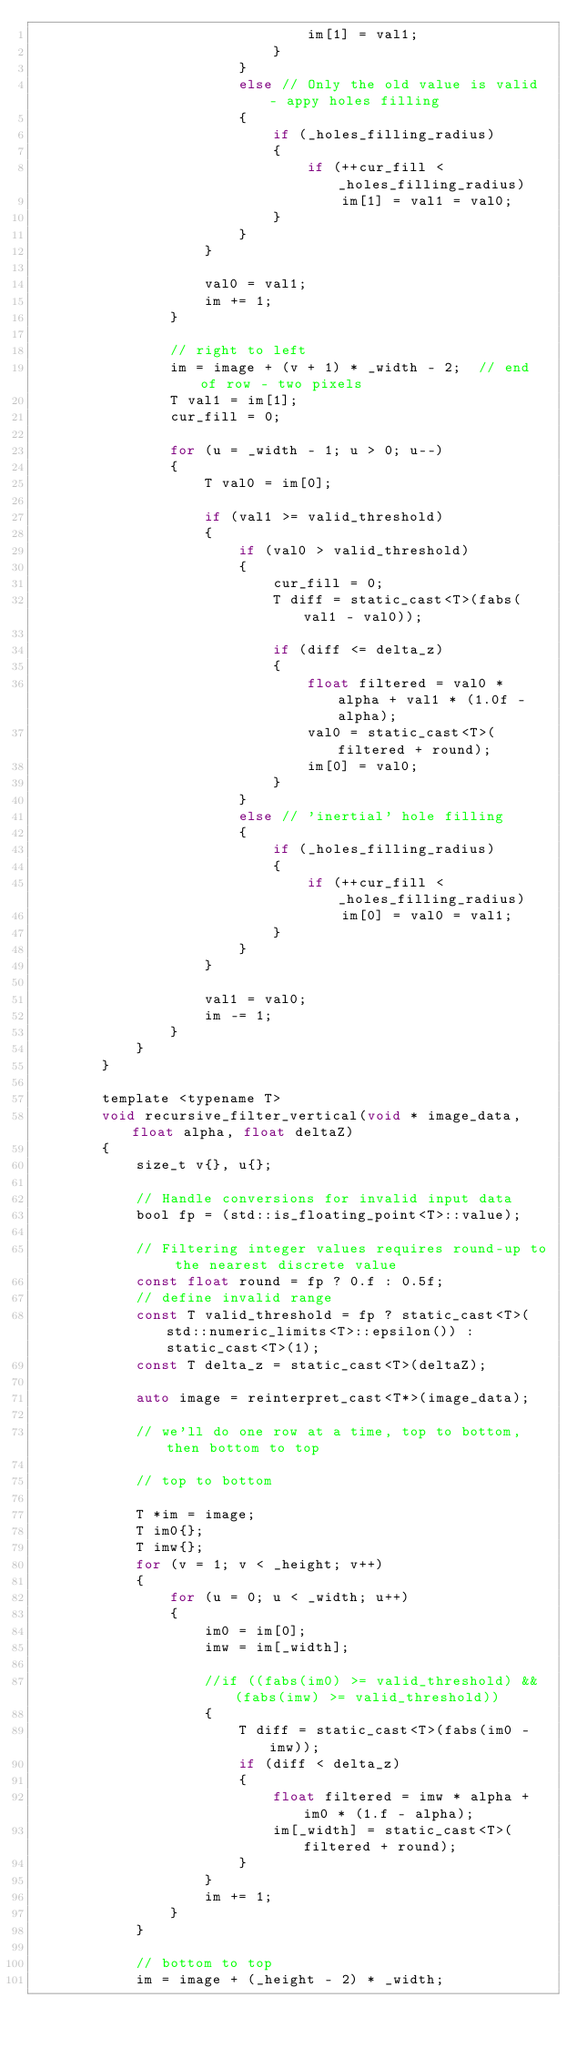<code> <loc_0><loc_0><loc_500><loc_500><_C_>                                im[1] = val1;
                            }
                        }
                        else // Only the old value is valid - appy holes filling
                        {
                            if (_holes_filling_radius)
                            {
                                if (++cur_fill <_holes_filling_radius)
                                    im[1] = val1 = val0;
                            }
                        }
                    }

                    val0 = val1;
                    im += 1;
                }

                // right to left
                im = image + (v + 1) * _width - 2;  // end of row - two pixels
                T val1 = im[1];
                cur_fill = 0;

                for (u = _width - 1; u > 0; u--)
                {
                    T val0 = im[0];

                    if (val1 >= valid_threshold)
                    {
                        if (val0 > valid_threshold)
                        {
                            cur_fill = 0;
                            T diff = static_cast<T>(fabs(val1 - val0));

                            if (diff <= delta_z)
                            {
                                float filtered = val0 * alpha + val1 * (1.0f - alpha);
                                val0 = static_cast<T>(filtered + round);
                                im[0] = val0;
                            }
                        }
                        else // 'inertial' hole filling
                        {
                            if (_holes_filling_radius)
                            {
                                if (++cur_fill <_holes_filling_radius)
                                    im[0] = val0 = val1;
                            }
                        }
                    }

                    val1 = val0;
                    im -= 1;
                }
            }
        }

        template <typename T>
        void recursive_filter_vertical(void * image_data, float alpha, float deltaZ)
        {
            size_t v{}, u{};

            // Handle conversions for invalid input data
            bool fp = (std::is_floating_point<T>::value);

            // Filtering integer values requires round-up to the nearest discrete value
            const float round = fp ? 0.f : 0.5f;
            // define invalid range
            const T valid_threshold = fp ? static_cast<T>(std::numeric_limits<T>::epsilon()) : static_cast<T>(1);
            const T delta_z = static_cast<T>(deltaZ);

            auto image = reinterpret_cast<T*>(image_data);

            // we'll do one row at a time, top to bottom, then bottom to top

            // top to bottom

            T *im = image;
            T im0{};
            T imw{};
            for (v = 1; v < _height; v++)
            {
                for (u = 0; u < _width; u++)
                {
                    im0 = im[0];
                    imw = im[_width];

                    //if ((fabs(im0) >= valid_threshold) && (fabs(imw) >= valid_threshold))
                    {
                        T diff = static_cast<T>(fabs(im0 - imw));
                        if (diff < delta_z)
                        {
                            float filtered = imw * alpha + im0 * (1.f - alpha);
                            im[_width] = static_cast<T>(filtered + round);
                        }
                    }
                    im += 1;
                }
            }

            // bottom to top
            im = image + (_height - 2) * _width;</code> 